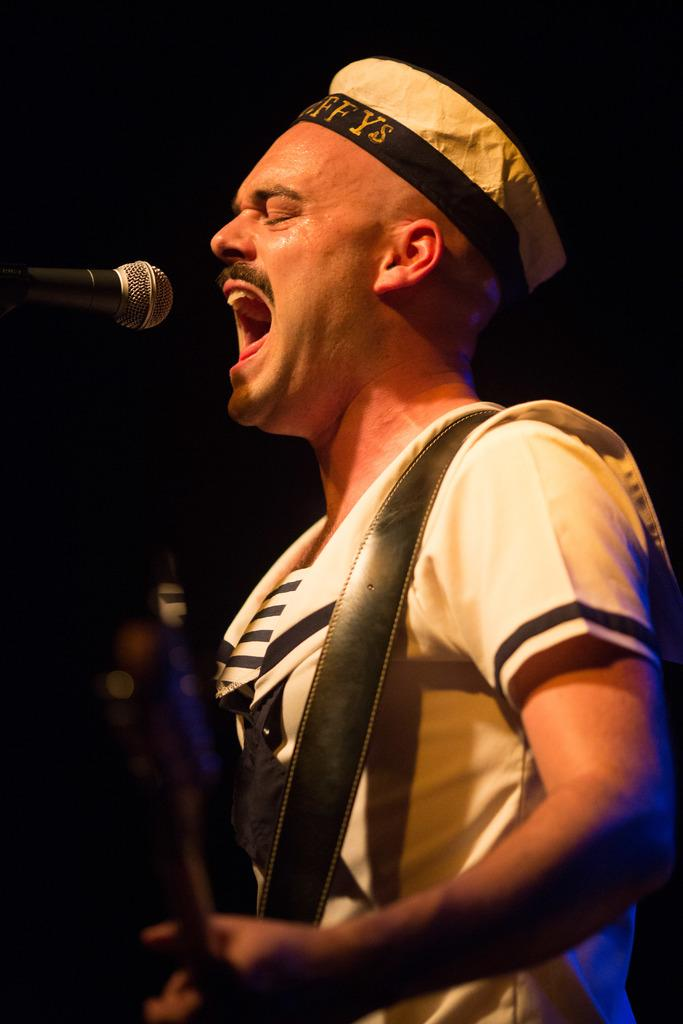What is the main subject of the image? There is a person in the image. What is the person wearing? The person is wearing a cap. What object is the person holding? The person is holding a guitar. What can be seen behind the person? The person is standing in front of a microphone. How many kittens are sitting on the microphone in the image? There are no kittens present in the image, so it is not possible to determine how many might be sitting on the microphone. 